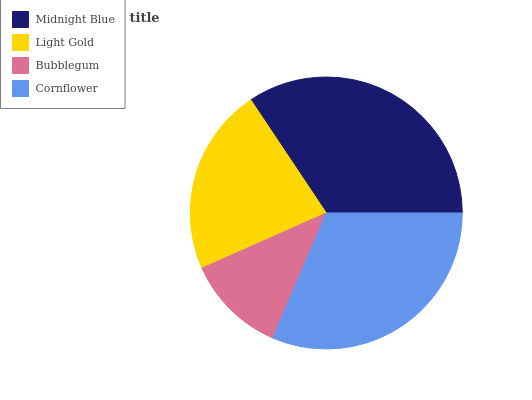Is Bubblegum the minimum?
Answer yes or no. Yes. Is Midnight Blue the maximum?
Answer yes or no. Yes. Is Light Gold the minimum?
Answer yes or no. No. Is Light Gold the maximum?
Answer yes or no. No. Is Midnight Blue greater than Light Gold?
Answer yes or no. Yes. Is Light Gold less than Midnight Blue?
Answer yes or no. Yes. Is Light Gold greater than Midnight Blue?
Answer yes or no. No. Is Midnight Blue less than Light Gold?
Answer yes or no. No. Is Cornflower the high median?
Answer yes or no. Yes. Is Light Gold the low median?
Answer yes or no. Yes. Is Midnight Blue the high median?
Answer yes or no. No. Is Midnight Blue the low median?
Answer yes or no. No. 